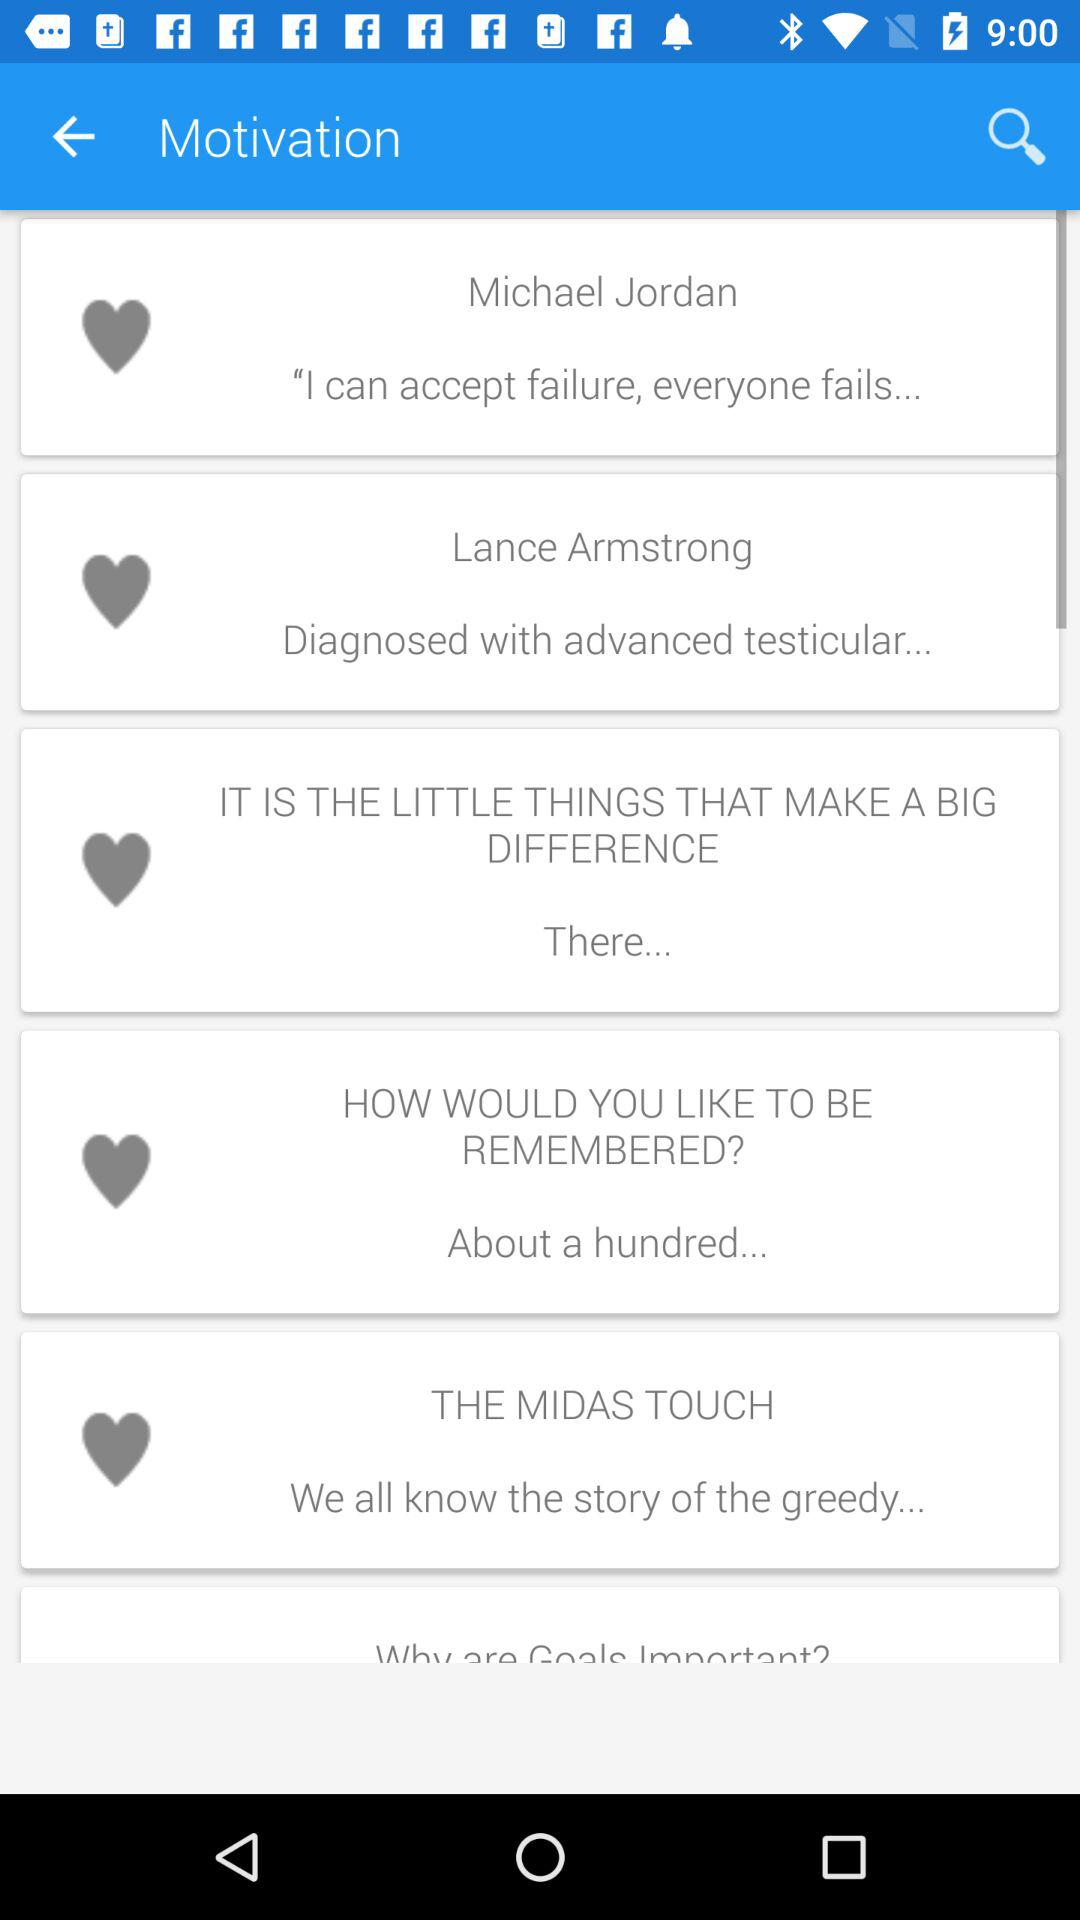What is the motivational quote by Michael Jordan? Michael Jordan's motivational quote is "I can accept failure, everyone fails...". 